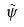Convert formula to latex. <formula><loc_0><loc_0><loc_500><loc_500>\tilde { \psi }</formula> 